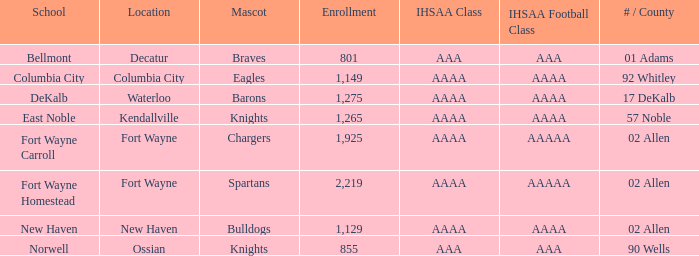What is the name of the school that has a spartan mascot, belongs to the aaaa ihsaa class, and has more than 1,275 students enrolled? Fort Wayne Homestead. 